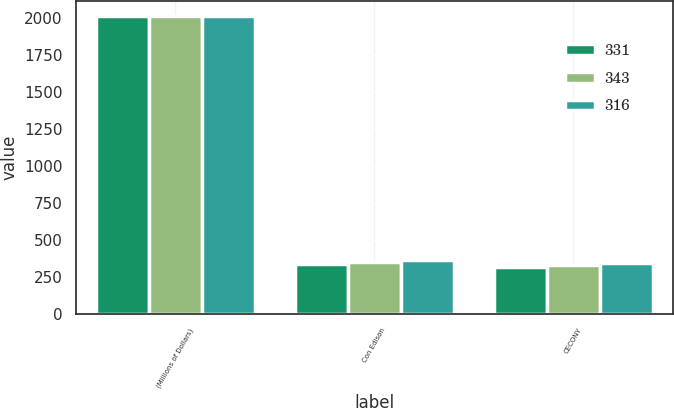Convert chart to OTSL. <chart><loc_0><loc_0><loc_500><loc_500><stacked_bar_chart><ecel><fcel>(Millions of Dollars)<fcel>Con Edison<fcel>CECONY<nl><fcel>331<fcel>2016<fcel>336<fcel>316<nl><fcel>343<fcel>2015<fcel>354<fcel>331<nl><fcel>316<fcel>2014<fcel>365<fcel>343<nl></chart> 